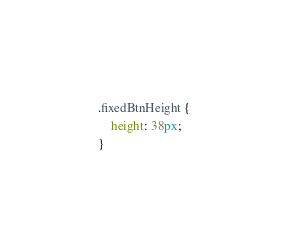Convert code to text. <code><loc_0><loc_0><loc_500><loc_500><_CSS_>.fixedBtnHeight {
    height: 38px;
}</code> 